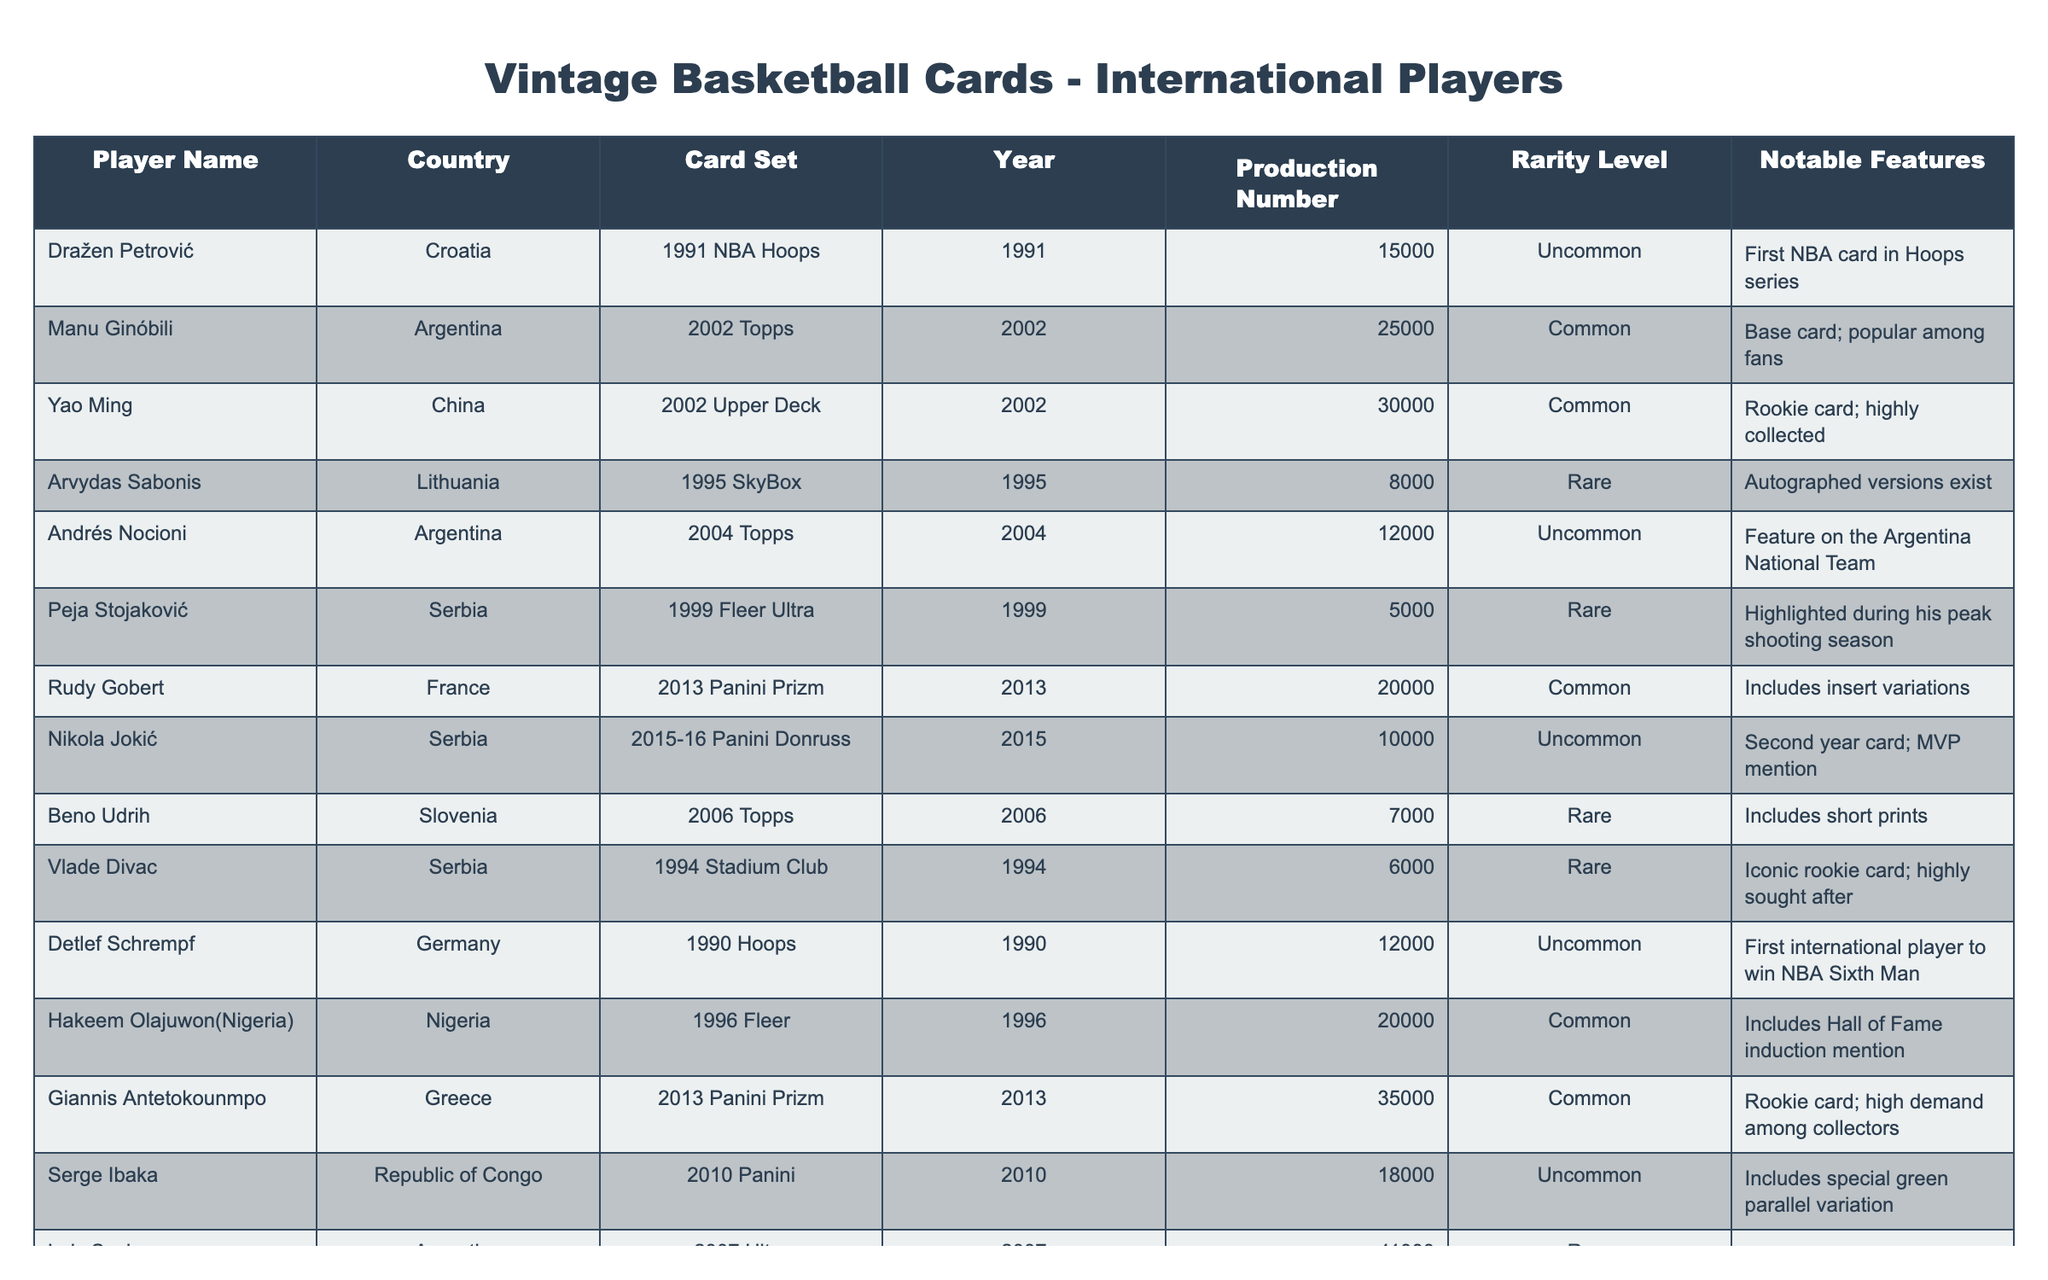What is the rarity level of Dražen Petrović's card? The table lists Dražen Petrović's card under the column "Rarity Level," which indicates it is categorized as "Uncommon."
Answer: Uncommon Which player has the lowest production number? By examining the "Production Number" column, Peja Stojaković's card has the lowest production number at 5000.
Answer: 5000 Is Hakeem Olajuwon's card considered rare? The rarity level of Hakeem Olajuwon's card is classified as "Common," according to the table. Therefore, it is not considered rare.
Answer: No What is the total production number of the cards for players from Serbia? The production numbers for Serbian players are: Peja Stojaković (5000), Nikola Jokić (10000), and Vlade Divac (6000), totaling 5000 + 10000 + 6000 = 21000.
Answer: 21000 Which player features a card with an autographed version? The table indicates that Arvydas Sabonis's card has autographed versions, as stated in the "Notable Features" column.
Answer: Arvydas Sabonis Are there any cards from the year 2010 listed in the table? Looking through the "Year" column, there is a card listed for Serge Ibaka from the year 2010. This confirms that there are cards from that year in the table.
Answer: Yes What is the difference in production numbers between Yao Ming’s and Giannis Antetokounmpo’s cards? The production number for Yao Ming's card is 30000, and for Giannis Antetokounmpo's card, it is 35000. The difference is calculated as 35000 - 30000 = 5000.
Answer: 5000 Which player’s card is unique for being the first international player to win NBA Sixth Man? The table specifies that Detlef Schrempf is noted as the first international player to win NBA Sixth Man in the "Notable Features" column of his card.
Answer: Detlef Schrempf What percentage of the featured cards are classified as Rare? The total number of cards is 12, and those classified as Rare are: Arvydas Sabonis, Peja Stojaković, Beno Udrih, Vlade Divac, and Luis Scola (5 cards). Therefore, the percentage is (5/12) * 100 = 41.67%.
Answer: 41.67% 